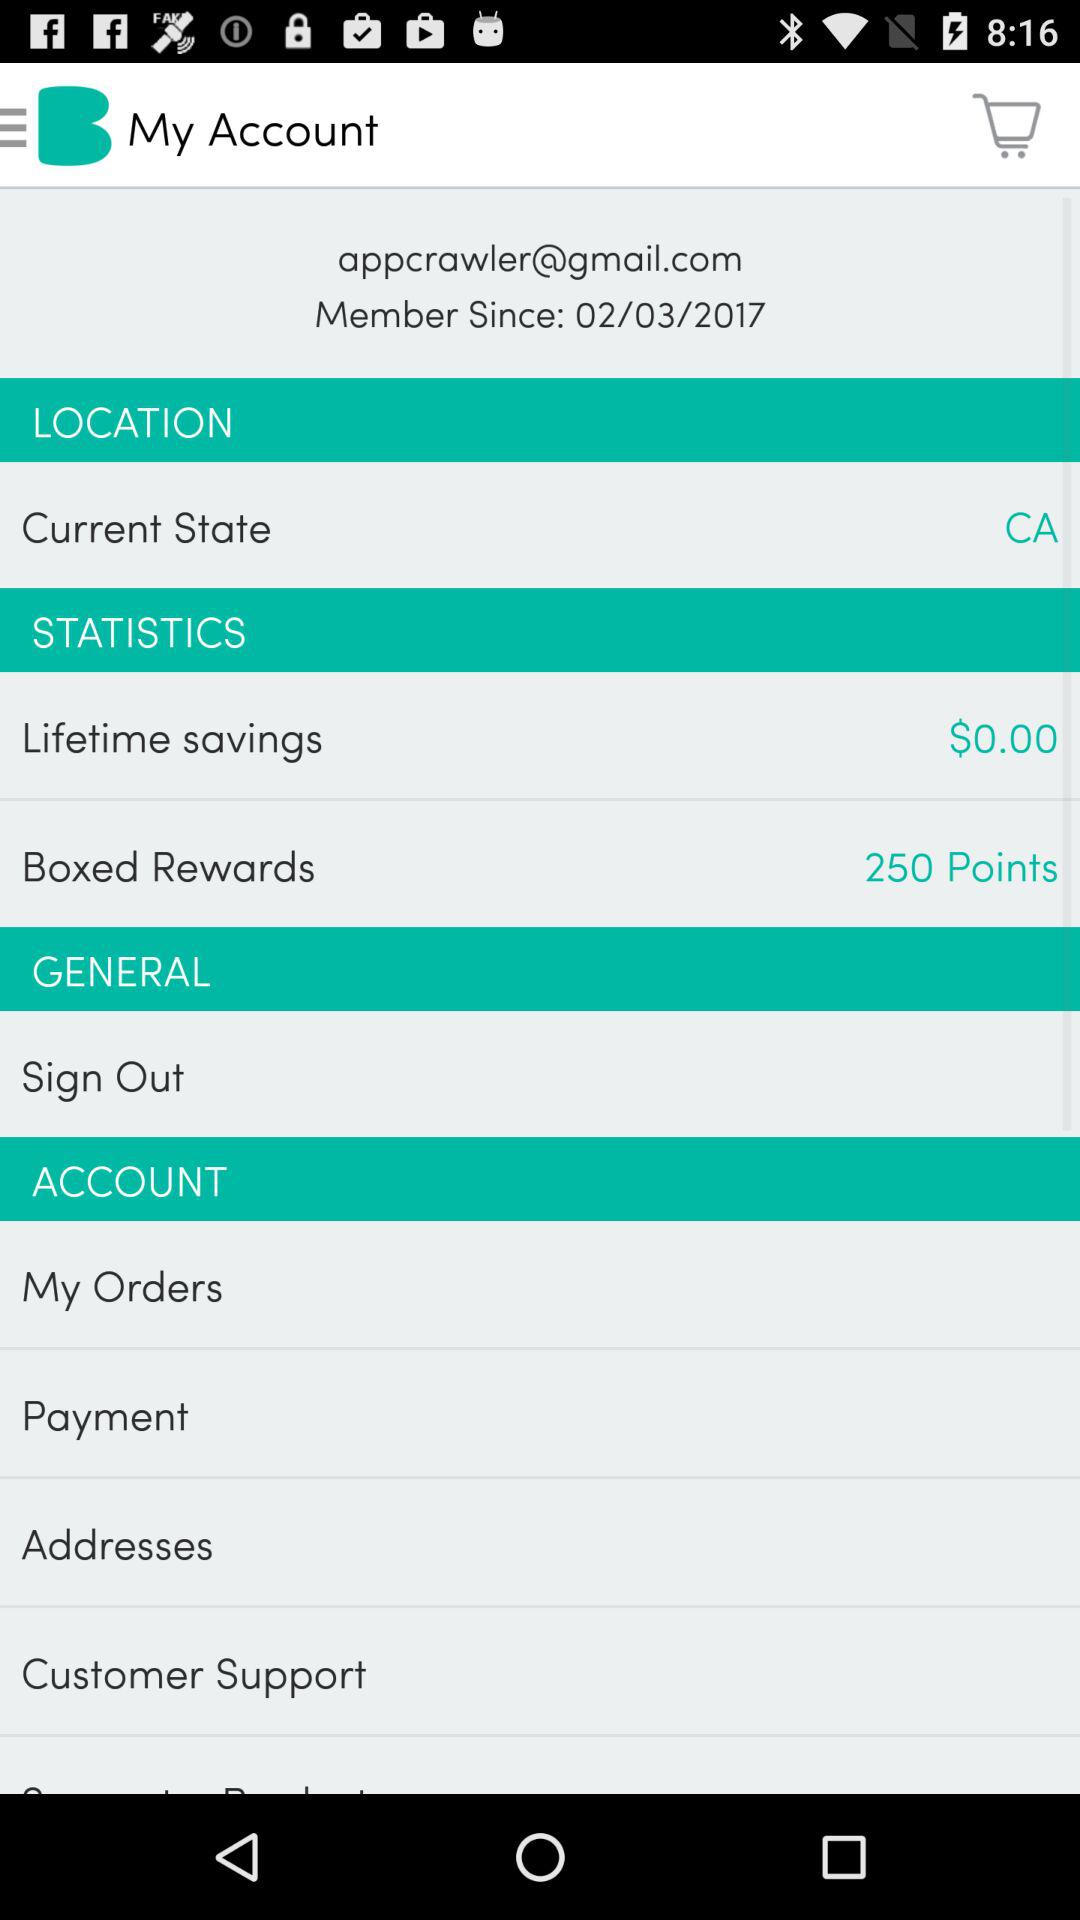How many orders does the user have?
When the provided information is insufficient, respond with <no answer>. <no answer> 